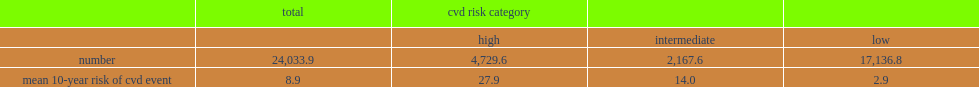For the population aged 20 to 79, how many percent of the 10-year risk of a cvd event? 8.9. How many percent of adults were classified as high-risk? 4,729.6. How many percent of adults were classified as intermediate-risk? 2,167.6. How many percent of adults were classified as low-risk? 17,136.8. What was the mean 10-year risk of a cvd event for high-risk? 27.9. What was the mean 10-year risk of a cvd event for intermediate-risk? 14.0. What was the mean 10-year risk of a cvd event for low-risk adults? 2.9. 